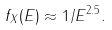Convert formula to latex. <formula><loc_0><loc_0><loc_500><loc_500>f _ { X } ( E ) \approx 1 / E ^ { 2 . 5 } .</formula> 